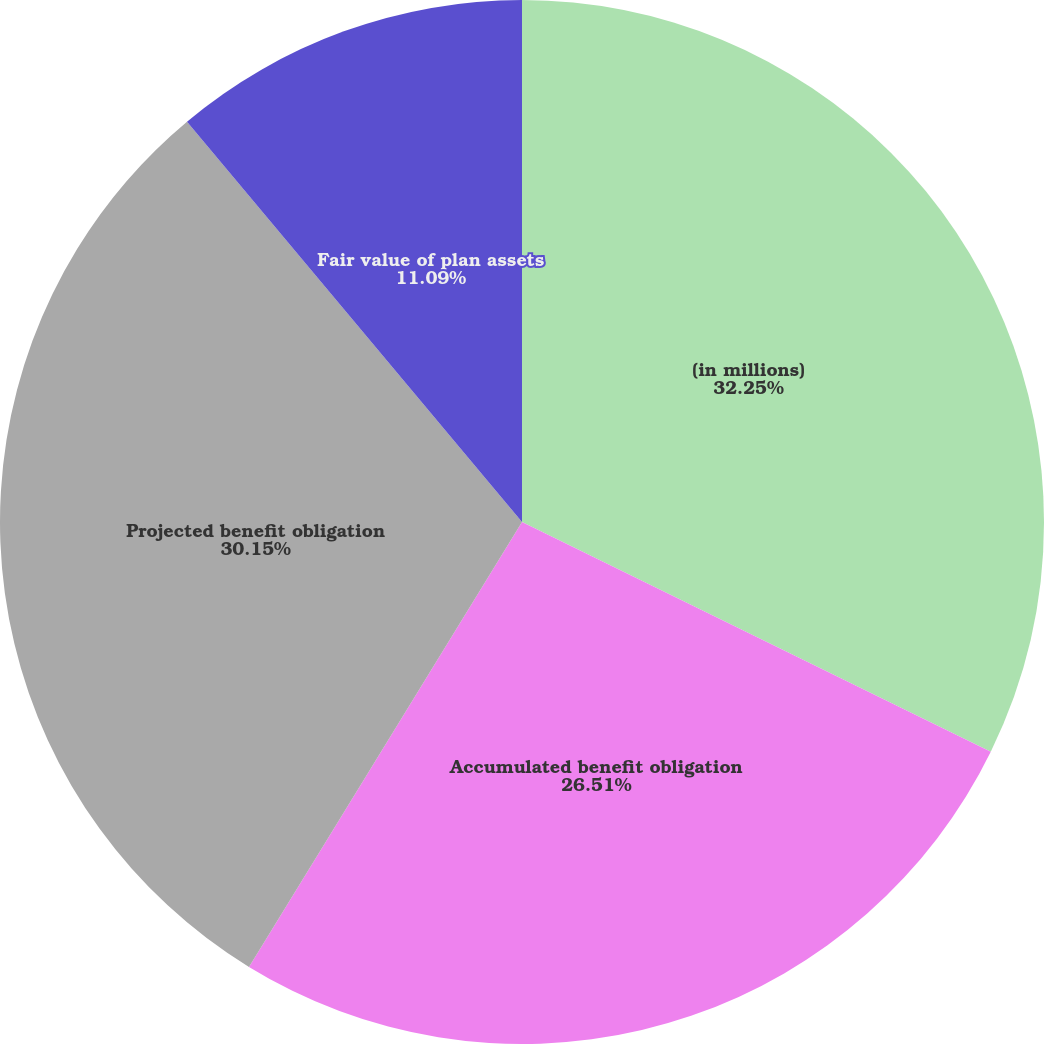Convert chart. <chart><loc_0><loc_0><loc_500><loc_500><pie_chart><fcel>(in millions)<fcel>Accumulated benefit obligation<fcel>Projected benefit obligation<fcel>Fair value of plan assets<nl><fcel>32.25%<fcel>26.51%<fcel>30.15%<fcel>11.09%<nl></chart> 